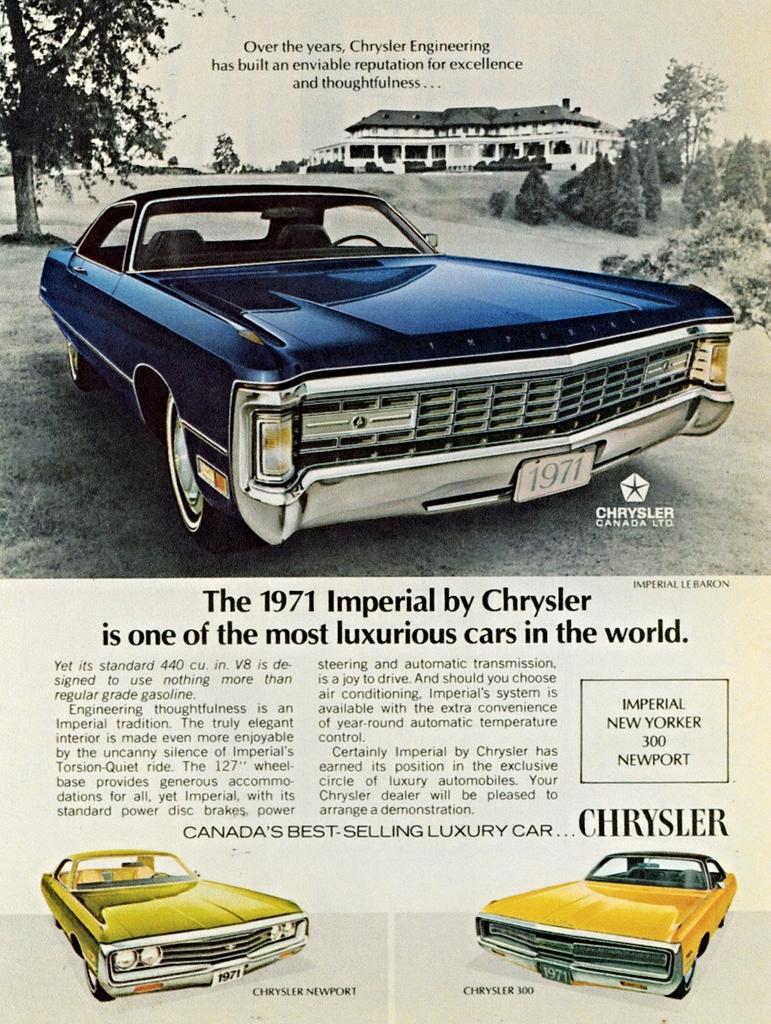Can you describe this image briefly? In this image there is a paper, on that paper there is some text and cars. 